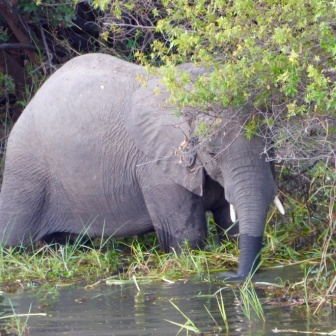Why do you think the elephant chose this specific spot? Elephants are known to seek out areas with abundant food and water sources. This particular spot offers both lush vegetation and fresh water, making it an ideal location for the elephant to find nourishment and hydration. 